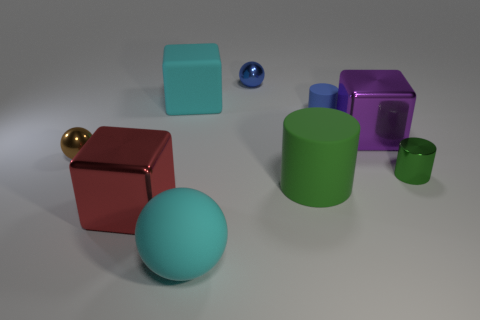There is a metal cylinder; is it the same color as the small shiny sphere that is behind the large cyan rubber block?
Make the answer very short. No. What is the ball that is left of the red metal cube made of?
Your answer should be compact. Metal. Are there any small rubber cylinders that have the same color as the small rubber thing?
Your answer should be compact. No. There is a cylinder that is the same size as the cyan sphere; what color is it?
Provide a short and direct response. Green. What number of large objects are blue rubber cylinders or gray objects?
Your answer should be compact. 0. Is the number of tiny brown objects that are in front of the large green matte object the same as the number of big things in front of the blue cylinder?
Your response must be concise. No. What number of matte spheres have the same size as the cyan matte cube?
Provide a short and direct response. 1. What number of brown things are either tiny spheres or big metal objects?
Give a very brief answer. 1. Is the number of small matte cylinders that are behind the big green cylinder the same as the number of big red metal things?
Provide a short and direct response. Yes. What size is the block that is in front of the brown shiny thing?
Ensure brevity in your answer.  Large. 